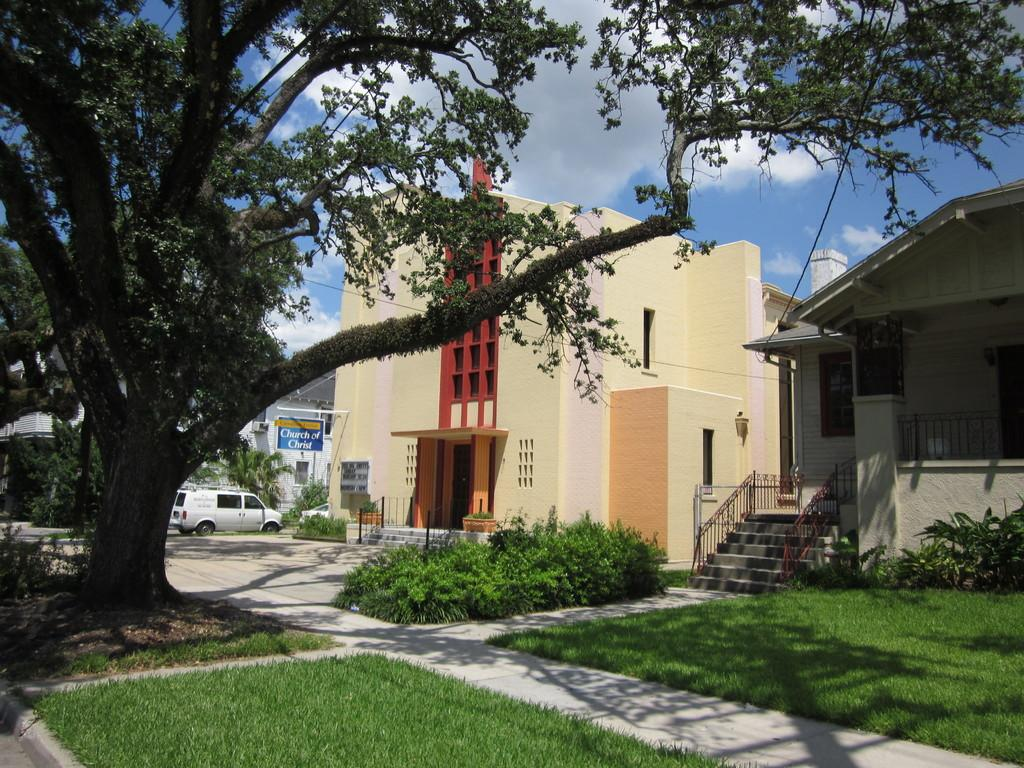What type of structures can be seen in the image? There are buildings in the image. What vehicle is parked on the side of the image? A car is parked on the side of the image. What type of vegetation is present in the image? There are trees and plants in the image. What is the ground covered with in the image? Grass is present on the ground in the image. How would you describe the sky in the image? The sky is blue and cloudy in the image. What type of prose is being recited by the house in the image? There is no house or prose present in the image; it features buildings, a car, trees, plants, grass, and a blue and cloudy sky. What is the frame made of in the image? There is no frame present in the image. 